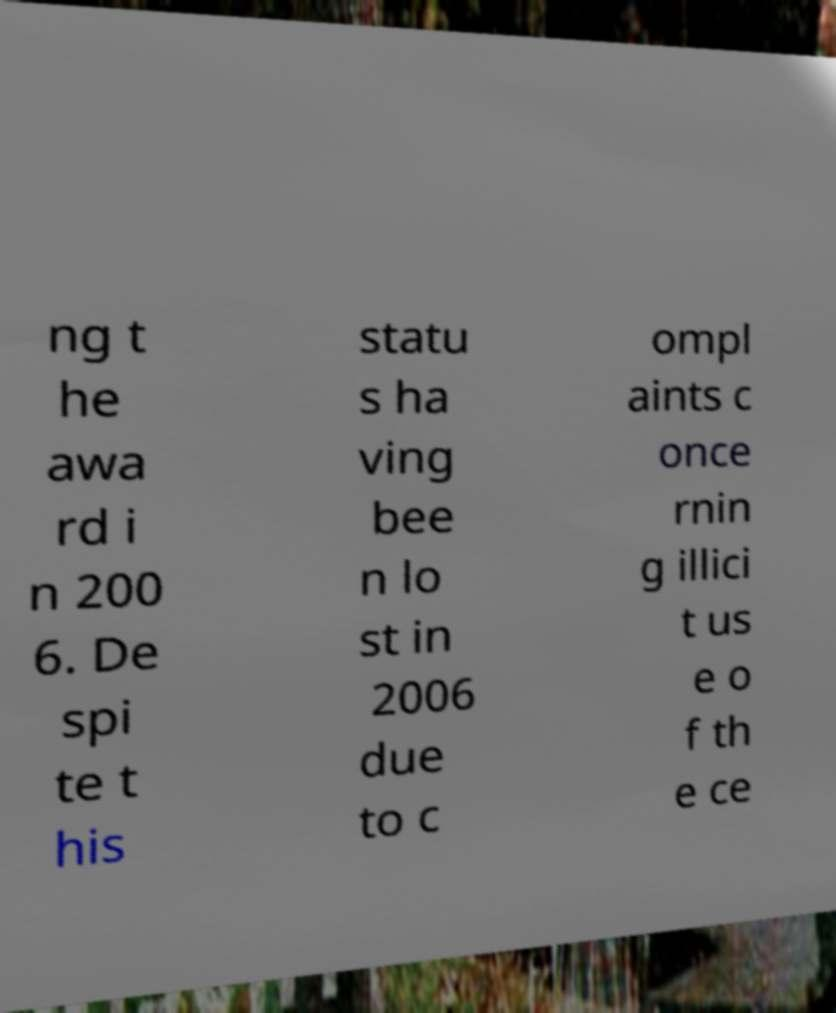Please identify and transcribe the text found in this image. ng t he awa rd i n 200 6. De spi te t his statu s ha ving bee n lo st in 2006 due to c ompl aints c once rnin g illici t us e o f th e ce 